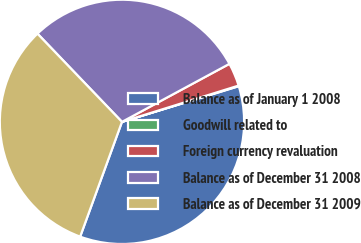<chart> <loc_0><loc_0><loc_500><loc_500><pie_chart><fcel>Balance as of January 1 2008<fcel>Goodwill related to<fcel>Foreign currency revaluation<fcel>Balance as of December 31 2008<fcel>Balance as of December 31 2009<nl><fcel>35.28%<fcel>0.08%<fcel>3.08%<fcel>29.28%<fcel>32.28%<nl></chart> 